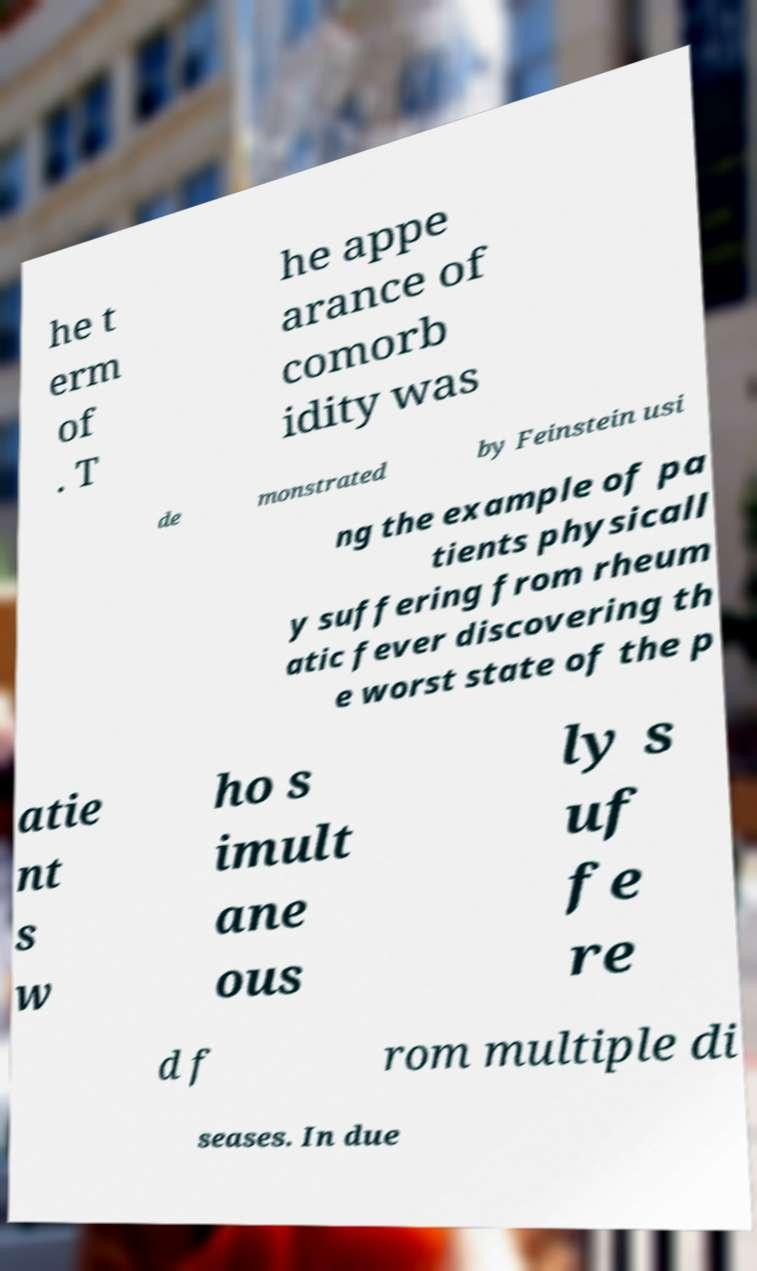Could you assist in decoding the text presented in this image and type it out clearly? he t erm of . T he appe arance of comorb idity was de monstrated by Feinstein usi ng the example of pa tients physicall y suffering from rheum atic fever discovering th e worst state of the p atie nt s w ho s imult ane ous ly s uf fe re d f rom multiple di seases. In due 